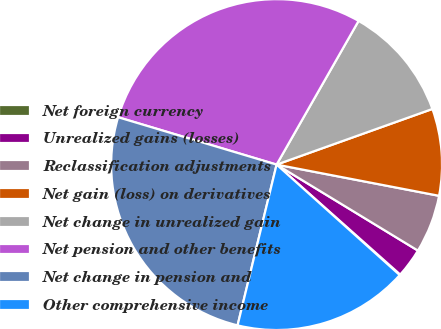<chart> <loc_0><loc_0><loc_500><loc_500><pie_chart><fcel>Net foreign currency<fcel>Unrealized gains (losses)<fcel>Reclassification adjustments<fcel>Net gain (loss) on derivatives<fcel>Net change in unrealized gain<fcel>Net pension and other benefits<fcel>Net change in pension and<fcel>Other comprehensive income<nl><fcel>0.07%<fcel>2.87%<fcel>5.68%<fcel>8.48%<fcel>11.29%<fcel>28.63%<fcel>25.83%<fcel>17.15%<nl></chart> 